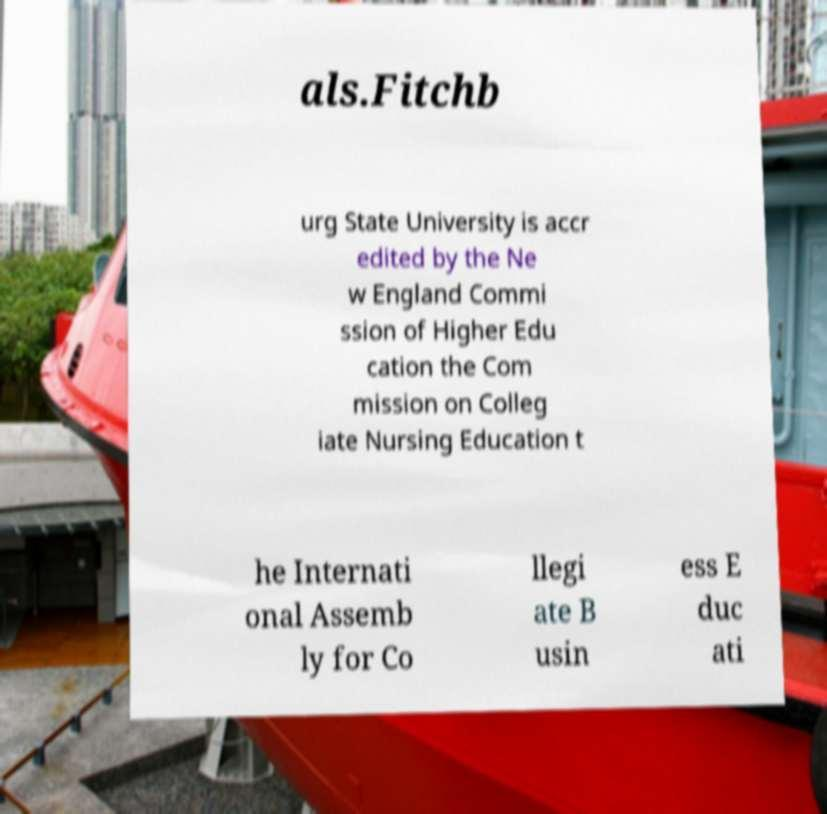Please read and relay the text visible in this image. What does it say? als.Fitchb urg State University is accr edited by the Ne w England Commi ssion of Higher Edu cation the Com mission on Colleg iate Nursing Education t he Internati onal Assemb ly for Co llegi ate B usin ess E duc ati 